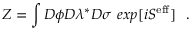<formula> <loc_0><loc_0><loc_500><loc_500>Z = \int D \phi D \lambda ^ { * } D \sigma \, e x p [ i S ^ { e f f } ] \, .</formula> 